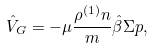<formula> <loc_0><loc_0><loc_500><loc_500>\hat { V } _ { G } = - \mu \frac { \rho ^ { ( 1 ) } n } { m } \hat { \beta } { \Sigma } { p } ,</formula> 